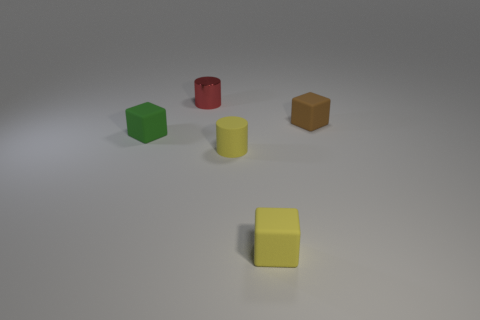There is a rubber thing that is the same shape as the red metallic object; what is its color?
Your response must be concise. Yellow. What is the size of the brown thing that is the same shape as the small green thing?
Offer a very short reply. Small. There is a cube that is left of the tiny thing behind the tiny brown rubber cube; what number of tiny yellow rubber blocks are behind it?
Your answer should be very brief. 0. What is the shape of the red object?
Make the answer very short. Cylinder. What number of blocks are the same material as the red cylinder?
Provide a short and direct response. 0. There is a small cylinder that is made of the same material as the yellow block; what is its color?
Give a very brief answer. Yellow. Is the size of the yellow cube the same as the yellow thing on the left side of the yellow rubber block?
Give a very brief answer. Yes. What is the material of the cylinder that is in front of the small rubber block behind the tiny block on the left side of the red metallic cylinder?
Your answer should be compact. Rubber. How many things are large purple metallic cylinders or cubes?
Make the answer very short. 3. Do the small cylinder in front of the brown matte object and the small matte object that is in front of the yellow matte cylinder have the same color?
Offer a very short reply. Yes. 